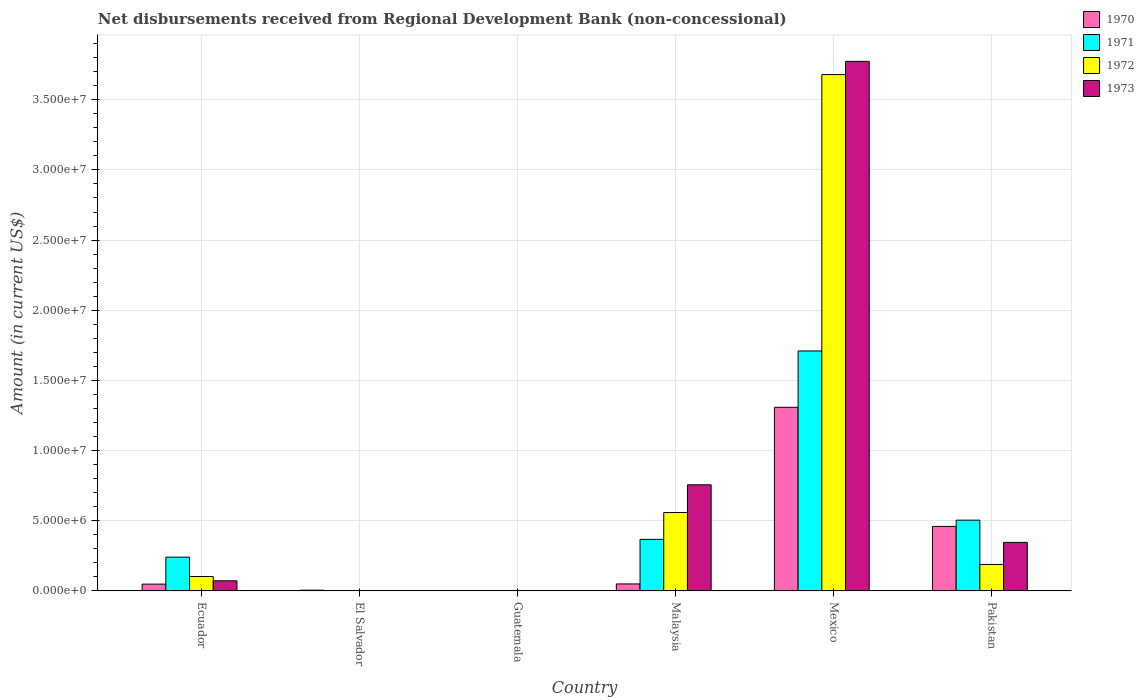How many different coloured bars are there?
Give a very brief answer. 4. What is the amount of disbursements received from Regional Development Bank in 1970 in Ecuador?
Ensure brevity in your answer.  4.89e+05. Across all countries, what is the maximum amount of disbursements received from Regional Development Bank in 1973?
Your answer should be compact. 3.77e+07. What is the total amount of disbursements received from Regional Development Bank in 1970 in the graph?
Ensure brevity in your answer.  1.87e+07. What is the difference between the amount of disbursements received from Regional Development Bank in 1972 in Mexico and that in Pakistan?
Provide a short and direct response. 3.49e+07. What is the difference between the amount of disbursements received from Regional Development Bank in 1970 in El Salvador and the amount of disbursements received from Regional Development Bank in 1971 in Pakistan?
Your response must be concise. -4.99e+06. What is the average amount of disbursements received from Regional Development Bank in 1973 per country?
Provide a short and direct response. 8.25e+06. What is the difference between the amount of disbursements received from Regional Development Bank of/in 1970 and amount of disbursements received from Regional Development Bank of/in 1972 in Ecuador?
Ensure brevity in your answer.  -5.42e+05. In how many countries, is the amount of disbursements received from Regional Development Bank in 1973 greater than 5000000 US$?
Provide a short and direct response. 2. What is the ratio of the amount of disbursements received from Regional Development Bank in 1971 in Ecuador to that in Pakistan?
Offer a terse response. 0.48. Is the amount of disbursements received from Regional Development Bank in 1971 in Malaysia less than that in Mexico?
Keep it short and to the point. Yes. Is the difference between the amount of disbursements received from Regional Development Bank in 1970 in Malaysia and Pakistan greater than the difference between the amount of disbursements received from Regional Development Bank in 1972 in Malaysia and Pakistan?
Provide a succinct answer. No. What is the difference between the highest and the second highest amount of disbursements received from Regional Development Bank in 1972?
Make the answer very short. 3.12e+07. What is the difference between the highest and the lowest amount of disbursements received from Regional Development Bank in 1970?
Your answer should be very brief. 1.31e+07. In how many countries, is the amount of disbursements received from Regional Development Bank in 1970 greater than the average amount of disbursements received from Regional Development Bank in 1970 taken over all countries?
Provide a short and direct response. 2. Is the sum of the amount of disbursements received from Regional Development Bank in 1970 in Malaysia and Mexico greater than the maximum amount of disbursements received from Regional Development Bank in 1973 across all countries?
Ensure brevity in your answer.  No. How many bars are there?
Keep it short and to the point. 17. Are all the bars in the graph horizontal?
Make the answer very short. No. How many countries are there in the graph?
Your answer should be compact. 6. What is the difference between two consecutive major ticks on the Y-axis?
Keep it short and to the point. 5.00e+06. Are the values on the major ticks of Y-axis written in scientific E-notation?
Offer a terse response. Yes. Does the graph contain any zero values?
Ensure brevity in your answer.  Yes. Does the graph contain grids?
Offer a terse response. Yes. Where does the legend appear in the graph?
Offer a very short reply. Top right. How are the legend labels stacked?
Ensure brevity in your answer.  Vertical. What is the title of the graph?
Offer a terse response. Net disbursements received from Regional Development Bank (non-concessional). Does "1961" appear as one of the legend labels in the graph?
Provide a succinct answer. No. What is the label or title of the X-axis?
Your answer should be very brief. Country. What is the label or title of the Y-axis?
Make the answer very short. Amount (in current US$). What is the Amount (in current US$) in 1970 in Ecuador?
Your response must be concise. 4.89e+05. What is the Amount (in current US$) of 1971 in Ecuador?
Your answer should be very brief. 2.41e+06. What is the Amount (in current US$) of 1972 in Ecuador?
Offer a terse response. 1.03e+06. What is the Amount (in current US$) in 1973 in Ecuador?
Provide a short and direct response. 7.26e+05. What is the Amount (in current US$) in 1970 in El Salvador?
Your response must be concise. 5.70e+04. What is the Amount (in current US$) in 1972 in El Salvador?
Give a very brief answer. 0. What is the Amount (in current US$) of 1973 in El Salvador?
Ensure brevity in your answer.  0. What is the Amount (in current US$) in 1970 in Guatemala?
Offer a very short reply. 0. What is the Amount (in current US$) of 1972 in Guatemala?
Give a very brief answer. 0. What is the Amount (in current US$) in 1973 in Guatemala?
Make the answer very short. 0. What is the Amount (in current US$) of 1970 in Malaysia?
Your response must be concise. 5.02e+05. What is the Amount (in current US$) in 1971 in Malaysia?
Your answer should be very brief. 3.68e+06. What is the Amount (in current US$) of 1972 in Malaysia?
Ensure brevity in your answer.  5.59e+06. What is the Amount (in current US$) in 1973 in Malaysia?
Your answer should be compact. 7.57e+06. What is the Amount (in current US$) of 1970 in Mexico?
Make the answer very short. 1.31e+07. What is the Amount (in current US$) of 1971 in Mexico?
Your response must be concise. 1.71e+07. What is the Amount (in current US$) of 1972 in Mexico?
Provide a succinct answer. 3.68e+07. What is the Amount (in current US$) of 1973 in Mexico?
Ensure brevity in your answer.  3.77e+07. What is the Amount (in current US$) in 1970 in Pakistan?
Make the answer very short. 4.60e+06. What is the Amount (in current US$) in 1971 in Pakistan?
Your answer should be compact. 5.04e+06. What is the Amount (in current US$) of 1972 in Pakistan?
Give a very brief answer. 1.89e+06. What is the Amount (in current US$) in 1973 in Pakistan?
Your response must be concise. 3.46e+06. Across all countries, what is the maximum Amount (in current US$) of 1970?
Keep it short and to the point. 1.31e+07. Across all countries, what is the maximum Amount (in current US$) of 1971?
Provide a succinct answer. 1.71e+07. Across all countries, what is the maximum Amount (in current US$) in 1972?
Offer a very short reply. 3.68e+07. Across all countries, what is the maximum Amount (in current US$) in 1973?
Provide a succinct answer. 3.77e+07. Across all countries, what is the minimum Amount (in current US$) of 1971?
Ensure brevity in your answer.  0. Across all countries, what is the minimum Amount (in current US$) of 1972?
Keep it short and to the point. 0. Across all countries, what is the minimum Amount (in current US$) in 1973?
Ensure brevity in your answer.  0. What is the total Amount (in current US$) in 1970 in the graph?
Make the answer very short. 1.87e+07. What is the total Amount (in current US$) of 1971 in the graph?
Provide a short and direct response. 2.82e+07. What is the total Amount (in current US$) in 1972 in the graph?
Keep it short and to the point. 4.53e+07. What is the total Amount (in current US$) of 1973 in the graph?
Make the answer very short. 4.95e+07. What is the difference between the Amount (in current US$) of 1970 in Ecuador and that in El Salvador?
Your answer should be compact. 4.32e+05. What is the difference between the Amount (in current US$) of 1970 in Ecuador and that in Malaysia?
Make the answer very short. -1.30e+04. What is the difference between the Amount (in current US$) in 1971 in Ecuador and that in Malaysia?
Your answer should be very brief. -1.27e+06. What is the difference between the Amount (in current US$) of 1972 in Ecuador and that in Malaysia?
Offer a terse response. -4.56e+06. What is the difference between the Amount (in current US$) in 1973 in Ecuador and that in Malaysia?
Your response must be concise. -6.84e+06. What is the difference between the Amount (in current US$) of 1970 in Ecuador and that in Mexico?
Provide a short and direct response. -1.26e+07. What is the difference between the Amount (in current US$) of 1971 in Ecuador and that in Mexico?
Your answer should be very brief. -1.47e+07. What is the difference between the Amount (in current US$) in 1972 in Ecuador and that in Mexico?
Your response must be concise. -3.58e+07. What is the difference between the Amount (in current US$) in 1973 in Ecuador and that in Mexico?
Make the answer very short. -3.70e+07. What is the difference between the Amount (in current US$) in 1970 in Ecuador and that in Pakistan?
Make the answer very short. -4.11e+06. What is the difference between the Amount (in current US$) of 1971 in Ecuador and that in Pakistan?
Offer a very short reply. -2.63e+06. What is the difference between the Amount (in current US$) in 1972 in Ecuador and that in Pakistan?
Offer a very short reply. -8.59e+05. What is the difference between the Amount (in current US$) in 1973 in Ecuador and that in Pakistan?
Ensure brevity in your answer.  -2.74e+06. What is the difference between the Amount (in current US$) in 1970 in El Salvador and that in Malaysia?
Offer a very short reply. -4.45e+05. What is the difference between the Amount (in current US$) in 1970 in El Salvador and that in Mexico?
Your answer should be compact. -1.30e+07. What is the difference between the Amount (in current US$) in 1970 in El Salvador and that in Pakistan?
Your answer should be compact. -4.54e+06. What is the difference between the Amount (in current US$) of 1970 in Malaysia and that in Mexico?
Give a very brief answer. -1.26e+07. What is the difference between the Amount (in current US$) in 1971 in Malaysia and that in Mexico?
Ensure brevity in your answer.  -1.34e+07. What is the difference between the Amount (in current US$) of 1972 in Malaysia and that in Mexico?
Offer a very short reply. -3.12e+07. What is the difference between the Amount (in current US$) of 1973 in Malaysia and that in Mexico?
Your answer should be compact. -3.02e+07. What is the difference between the Amount (in current US$) of 1970 in Malaysia and that in Pakistan?
Your response must be concise. -4.10e+06. What is the difference between the Amount (in current US$) of 1971 in Malaysia and that in Pakistan?
Provide a succinct answer. -1.37e+06. What is the difference between the Amount (in current US$) of 1972 in Malaysia and that in Pakistan?
Ensure brevity in your answer.  3.70e+06. What is the difference between the Amount (in current US$) of 1973 in Malaysia and that in Pakistan?
Offer a terse response. 4.10e+06. What is the difference between the Amount (in current US$) of 1970 in Mexico and that in Pakistan?
Offer a very short reply. 8.48e+06. What is the difference between the Amount (in current US$) of 1971 in Mexico and that in Pakistan?
Ensure brevity in your answer.  1.21e+07. What is the difference between the Amount (in current US$) of 1972 in Mexico and that in Pakistan?
Ensure brevity in your answer.  3.49e+07. What is the difference between the Amount (in current US$) of 1973 in Mexico and that in Pakistan?
Offer a terse response. 3.43e+07. What is the difference between the Amount (in current US$) in 1970 in Ecuador and the Amount (in current US$) in 1971 in Malaysia?
Give a very brief answer. -3.19e+06. What is the difference between the Amount (in current US$) in 1970 in Ecuador and the Amount (in current US$) in 1972 in Malaysia?
Your answer should be compact. -5.10e+06. What is the difference between the Amount (in current US$) in 1970 in Ecuador and the Amount (in current US$) in 1973 in Malaysia?
Offer a very short reply. -7.08e+06. What is the difference between the Amount (in current US$) of 1971 in Ecuador and the Amount (in current US$) of 1972 in Malaysia?
Offer a very short reply. -3.18e+06. What is the difference between the Amount (in current US$) of 1971 in Ecuador and the Amount (in current US$) of 1973 in Malaysia?
Your answer should be very brief. -5.16e+06. What is the difference between the Amount (in current US$) in 1972 in Ecuador and the Amount (in current US$) in 1973 in Malaysia?
Make the answer very short. -6.54e+06. What is the difference between the Amount (in current US$) in 1970 in Ecuador and the Amount (in current US$) in 1971 in Mexico?
Make the answer very short. -1.66e+07. What is the difference between the Amount (in current US$) in 1970 in Ecuador and the Amount (in current US$) in 1972 in Mexico?
Make the answer very short. -3.63e+07. What is the difference between the Amount (in current US$) of 1970 in Ecuador and the Amount (in current US$) of 1973 in Mexico?
Your response must be concise. -3.72e+07. What is the difference between the Amount (in current US$) in 1971 in Ecuador and the Amount (in current US$) in 1972 in Mexico?
Offer a terse response. -3.44e+07. What is the difference between the Amount (in current US$) in 1971 in Ecuador and the Amount (in current US$) in 1973 in Mexico?
Provide a short and direct response. -3.53e+07. What is the difference between the Amount (in current US$) of 1972 in Ecuador and the Amount (in current US$) of 1973 in Mexico?
Provide a short and direct response. -3.67e+07. What is the difference between the Amount (in current US$) in 1970 in Ecuador and the Amount (in current US$) in 1971 in Pakistan?
Offer a terse response. -4.56e+06. What is the difference between the Amount (in current US$) of 1970 in Ecuador and the Amount (in current US$) of 1972 in Pakistan?
Your response must be concise. -1.40e+06. What is the difference between the Amount (in current US$) of 1970 in Ecuador and the Amount (in current US$) of 1973 in Pakistan?
Provide a succinct answer. -2.97e+06. What is the difference between the Amount (in current US$) of 1971 in Ecuador and the Amount (in current US$) of 1972 in Pakistan?
Your answer should be very brief. 5.21e+05. What is the difference between the Amount (in current US$) of 1971 in Ecuador and the Amount (in current US$) of 1973 in Pakistan?
Provide a short and direct response. -1.05e+06. What is the difference between the Amount (in current US$) in 1972 in Ecuador and the Amount (in current US$) in 1973 in Pakistan?
Your answer should be very brief. -2.43e+06. What is the difference between the Amount (in current US$) of 1970 in El Salvador and the Amount (in current US$) of 1971 in Malaysia?
Your answer should be very brief. -3.62e+06. What is the difference between the Amount (in current US$) in 1970 in El Salvador and the Amount (in current US$) in 1972 in Malaysia?
Your answer should be very brief. -5.53e+06. What is the difference between the Amount (in current US$) in 1970 in El Salvador and the Amount (in current US$) in 1973 in Malaysia?
Offer a terse response. -7.51e+06. What is the difference between the Amount (in current US$) in 1970 in El Salvador and the Amount (in current US$) in 1971 in Mexico?
Offer a terse response. -1.70e+07. What is the difference between the Amount (in current US$) in 1970 in El Salvador and the Amount (in current US$) in 1972 in Mexico?
Give a very brief answer. -3.67e+07. What is the difference between the Amount (in current US$) in 1970 in El Salvador and the Amount (in current US$) in 1973 in Mexico?
Offer a very short reply. -3.77e+07. What is the difference between the Amount (in current US$) of 1970 in El Salvador and the Amount (in current US$) of 1971 in Pakistan?
Make the answer very short. -4.99e+06. What is the difference between the Amount (in current US$) in 1970 in El Salvador and the Amount (in current US$) in 1972 in Pakistan?
Keep it short and to the point. -1.83e+06. What is the difference between the Amount (in current US$) in 1970 in El Salvador and the Amount (in current US$) in 1973 in Pakistan?
Offer a terse response. -3.40e+06. What is the difference between the Amount (in current US$) in 1970 in Malaysia and the Amount (in current US$) in 1971 in Mexico?
Make the answer very short. -1.66e+07. What is the difference between the Amount (in current US$) of 1970 in Malaysia and the Amount (in current US$) of 1972 in Mexico?
Provide a succinct answer. -3.63e+07. What is the difference between the Amount (in current US$) in 1970 in Malaysia and the Amount (in current US$) in 1973 in Mexico?
Keep it short and to the point. -3.72e+07. What is the difference between the Amount (in current US$) in 1971 in Malaysia and the Amount (in current US$) in 1972 in Mexico?
Keep it short and to the point. -3.31e+07. What is the difference between the Amount (in current US$) of 1971 in Malaysia and the Amount (in current US$) of 1973 in Mexico?
Give a very brief answer. -3.41e+07. What is the difference between the Amount (in current US$) in 1972 in Malaysia and the Amount (in current US$) in 1973 in Mexico?
Ensure brevity in your answer.  -3.21e+07. What is the difference between the Amount (in current US$) of 1970 in Malaysia and the Amount (in current US$) of 1971 in Pakistan?
Your response must be concise. -4.54e+06. What is the difference between the Amount (in current US$) of 1970 in Malaysia and the Amount (in current US$) of 1972 in Pakistan?
Your answer should be compact. -1.39e+06. What is the difference between the Amount (in current US$) of 1970 in Malaysia and the Amount (in current US$) of 1973 in Pakistan?
Your answer should be compact. -2.96e+06. What is the difference between the Amount (in current US$) of 1971 in Malaysia and the Amount (in current US$) of 1972 in Pakistan?
Offer a terse response. 1.79e+06. What is the difference between the Amount (in current US$) in 1971 in Malaysia and the Amount (in current US$) in 1973 in Pakistan?
Offer a very short reply. 2.16e+05. What is the difference between the Amount (in current US$) of 1972 in Malaysia and the Amount (in current US$) of 1973 in Pakistan?
Provide a succinct answer. 2.13e+06. What is the difference between the Amount (in current US$) in 1970 in Mexico and the Amount (in current US$) in 1971 in Pakistan?
Ensure brevity in your answer.  8.04e+06. What is the difference between the Amount (in current US$) in 1970 in Mexico and the Amount (in current US$) in 1972 in Pakistan?
Provide a short and direct response. 1.12e+07. What is the difference between the Amount (in current US$) of 1970 in Mexico and the Amount (in current US$) of 1973 in Pakistan?
Provide a succinct answer. 9.62e+06. What is the difference between the Amount (in current US$) in 1971 in Mexico and the Amount (in current US$) in 1972 in Pakistan?
Provide a succinct answer. 1.52e+07. What is the difference between the Amount (in current US$) in 1971 in Mexico and the Amount (in current US$) in 1973 in Pakistan?
Your response must be concise. 1.36e+07. What is the difference between the Amount (in current US$) of 1972 in Mexico and the Amount (in current US$) of 1973 in Pakistan?
Your answer should be compact. 3.33e+07. What is the average Amount (in current US$) of 1970 per country?
Keep it short and to the point. 3.12e+06. What is the average Amount (in current US$) of 1971 per country?
Provide a succinct answer. 4.71e+06. What is the average Amount (in current US$) of 1972 per country?
Offer a very short reply. 7.55e+06. What is the average Amount (in current US$) of 1973 per country?
Offer a terse response. 8.25e+06. What is the difference between the Amount (in current US$) in 1970 and Amount (in current US$) in 1971 in Ecuador?
Give a very brief answer. -1.92e+06. What is the difference between the Amount (in current US$) in 1970 and Amount (in current US$) in 1972 in Ecuador?
Give a very brief answer. -5.42e+05. What is the difference between the Amount (in current US$) of 1970 and Amount (in current US$) of 1973 in Ecuador?
Your answer should be compact. -2.37e+05. What is the difference between the Amount (in current US$) of 1971 and Amount (in current US$) of 1972 in Ecuador?
Keep it short and to the point. 1.38e+06. What is the difference between the Amount (in current US$) of 1971 and Amount (in current US$) of 1973 in Ecuador?
Your response must be concise. 1.68e+06. What is the difference between the Amount (in current US$) in 1972 and Amount (in current US$) in 1973 in Ecuador?
Your answer should be very brief. 3.05e+05. What is the difference between the Amount (in current US$) of 1970 and Amount (in current US$) of 1971 in Malaysia?
Provide a succinct answer. -3.18e+06. What is the difference between the Amount (in current US$) in 1970 and Amount (in current US$) in 1972 in Malaysia?
Offer a terse response. -5.09e+06. What is the difference between the Amount (in current US$) in 1970 and Amount (in current US$) in 1973 in Malaysia?
Offer a terse response. -7.06e+06. What is the difference between the Amount (in current US$) in 1971 and Amount (in current US$) in 1972 in Malaysia?
Your response must be concise. -1.91e+06. What is the difference between the Amount (in current US$) of 1971 and Amount (in current US$) of 1973 in Malaysia?
Make the answer very short. -3.89e+06. What is the difference between the Amount (in current US$) of 1972 and Amount (in current US$) of 1973 in Malaysia?
Your response must be concise. -1.98e+06. What is the difference between the Amount (in current US$) of 1970 and Amount (in current US$) of 1971 in Mexico?
Your answer should be very brief. -4.02e+06. What is the difference between the Amount (in current US$) in 1970 and Amount (in current US$) in 1972 in Mexico?
Your response must be concise. -2.37e+07. What is the difference between the Amount (in current US$) in 1970 and Amount (in current US$) in 1973 in Mexico?
Offer a terse response. -2.46e+07. What is the difference between the Amount (in current US$) of 1971 and Amount (in current US$) of 1972 in Mexico?
Offer a very short reply. -1.97e+07. What is the difference between the Amount (in current US$) in 1971 and Amount (in current US$) in 1973 in Mexico?
Provide a succinct answer. -2.06e+07. What is the difference between the Amount (in current US$) in 1972 and Amount (in current US$) in 1973 in Mexico?
Give a very brief answer. -9.43e+05. What is the difference between the Amount (in current US$) in 1970 and Amount (in current US$) in 1971 in Pakistan?
Provide a short and direct response. -4.45e+05. What is the difference between the Amount (in current US$) of 1970 and Amount (in current US$) of 1972 in Pakistan?
Keep it short and to the point. 2.71e+06. What is the difference between the Amount (in current US$) of 1970 and Amount (in current US$) of 1973 in Pakistan?
Offer a very short reply. 1.14e+06. What is the difference between the Amount (in current US$) in 1971 and Amount (in current US$) in 1972 in Pakistan?
Ensure brevity in your answer.  3.16e+06. What is the difference between the Amount (in current US$) of 1971 and Amount (in current US$) of 1973 in Pakistan?
Keep it short and to the point. 1.58e+06. What is the difference between the Amount (in current US$) of 1972 and Amount (in current US$) of 1973 in Pakistan?
Your answer should be very brief. -1.57e+06. What is the ratio of the Amount (in current US$) in 1970 in Ecuador to that in El Salvador?
Your response must be concise. 8.58. What is the ratio of the Amount (in current US$) in 1970 in Ecuador to that in Malaysia?
Offer a very short reply. 0.97. What is the ratio of the Amount (in current US$) in 1971 in Ecuador to that in Malaysia?
Give a very brief answer. 0.66. What is the ratio of the Amount (in current US$) in 1972 in Ecuador to that in Malaysia?
Ensure brevity in your answer.  0.18. What is the ratio of the Amount (in current US$) in 1973 in Ecuador to that in Malaysia?
Make the answer very short. 0.1. What is the ratio of the Amount (in current US$) of 1970 in Ecuador to that in Mexico?
Offer a terse response. 0.04. What is the ratio of the Amount (in current US$) of 1971 in Ecuador to that in Mexico?
Provide a succinct answer. 0.14. What is the ratio of the Amount (in current US$) of 1972 in Ecuador to that in Mexico?
Make the answer very short. 0.03. What is the ratio of the Amount (in current US$) of 1973 in Ecuador to that in Mexico?
Give a very brief answer. 0.02. What is the ratio of the Amount (in current US$) in 1970 in Ecuador to that in Pakistan?
Offer a terse response. 0.11. What is the ratio of the Amount (in current US$) of 1971 in Ecuador to that in Pakistan?
Provide a succinct answer. 0.48. What is the ratio of the Amount (in current US$) of 1972 in Ecuador to that in Pakistan?
Offer a very short reply. 0.55. What is the ratio of the Amount (in current US$) in 1973 in Ecuador to that in Pakistan?
Offer a terse response. 0.21. What is the ratio of the Amount (in current US$) in 1970 in El Salvador to that in Malaysia?
Offer a very short reply. 0.11. What is the ratio of the Amount (in current US$) of 1970 in El Salvador to that in Mexico?
Give a very brief answer. 0. What is the ratio of the Amount (in current US$) in 1970 in El Salvador to that in Pakistan?
Your response must be concise. 0.01. What is the ratio of the Amount (in current US$) of 1970 in Malaysia to that in Mexico?
Your answer should be very brief. 0.04. What is the ratio of the Amount (in current US$) of 1971 in Malaysia to that in Mexico?
Provide a succinct answer. 0.21. What is the ratio of the Amount (in current US$) of 1972 in Malaysia to that in Mexico?
Your answer should be very brief. 0.15. What is the ratio of the Amount (in current US$) of 1973 in Malaysia to that in Mexico?
Provide a short and direct response. 0.2. What is the ratio of the Amount (in current US$) of 1970 in Malaysia to that in Pakistan?
Keep it short and to the point. 0.11. What is the ratio of the Amount (in current US$) of 1971 in Malaysia to that in Pakistan?
Your answer should be compact. 0.73. What is the ratio of the Amount (in current US$) of 1972 in Malaysia to that in Pakistan?
Your response must be concise. 2.96. What is the ratio of the Amount (in current US$) in 1973 in Malaysia to that in Pakistan?
Provide a short and direct response. 2.19. What is the ratio of the Amount (in current US$) in 1970 in Mexico to that in Pakistan?
Ensure brevity in your answer.  2.84. What is the ratio of the Amount (in current US$) in 1971 in Mexico to that in Pakistan?
Your answer should be very brief. 3.39. What is the ratio of the Amount (in current US$) of 1972 in Mexico to that in Pakistan?
Offer a very short reply. 19.47. What is the ratio of the Amount (in current US$) of 1973 in Mexico to that in Pakistan?
Provide a succinct answer. 10.9. What is the difference between the highest and the second highest Amount (in current US$) in 1970?
Offer a very short reply. 8.48e+06. What is the difference between the highest and the second highest Amount (in current US$) of 1971?
Your answer should be compact. 1.21e+07. What is the difference between the highest and the second highest Amount (in current US$) of 1972?
Provide a short and direct response. 3.12e+07. What is the difference between the highest and the second highest Amount (in current US$) of 1973?
Provide a succinct answer. 3.02e+07. What is the difference between the highest and the lowest Amount (in current US$) of 1970?
Make the answer very short. 1.31e+07. What is the difference between the highest and the lowest Amount (in current US$) of 1971?
Provide a short and direct response. 1.71e+07. What is the difference between the highest and the lowest Amount (in current US$) in 1972?
Your answer should be very brief. 3.68e+07. What is the difference between the highest and the lowest Amount (in current US$) in 1973?
Give a very brief answer. 3.77e+07. 